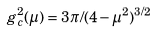Convert formula to latex. <formula><loc_0><loc_0><loc_500><loc_500>g _ { c } ^ { 2 } ( \mu ) = 3 \pi / ( 4 - \mu ^ { 2 } ) ^ { 3 / 2 }</formula> 